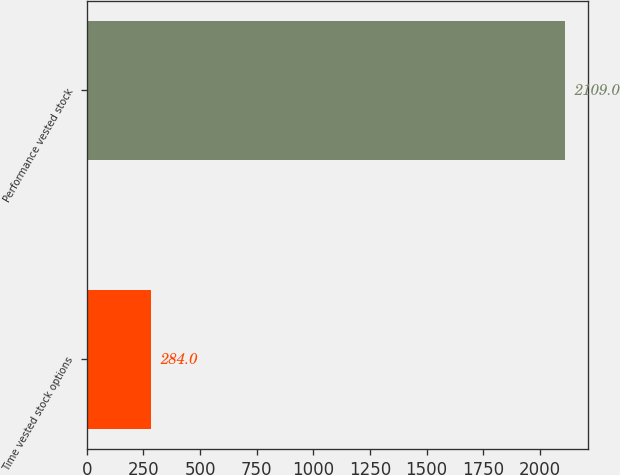<chart> <loc_0><loc_0><loc_500><loc_500><bar_chart><fcel>Time vested stock options<fcel>Performance vested stock<nl><fcel>284<fcel>2109<nl></chart> 